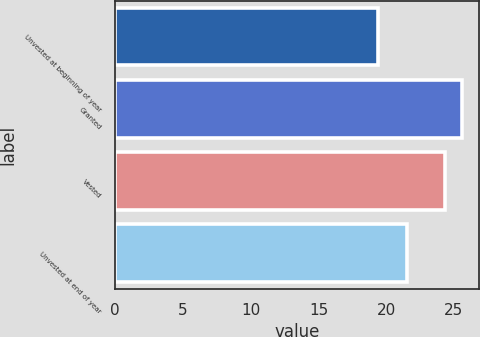Convert chart to OTSL. <chart><loc_0><loc_0><loc_500><loc_500><bar_chart><fcel>Unvested at beginning of year<fcel>Granted<fcel>Vested<fcel>Unvested at end of year<nl><fcel>19.36<fcel>25.59<fcel>24.31<fcel>21.53<nl></chart> 